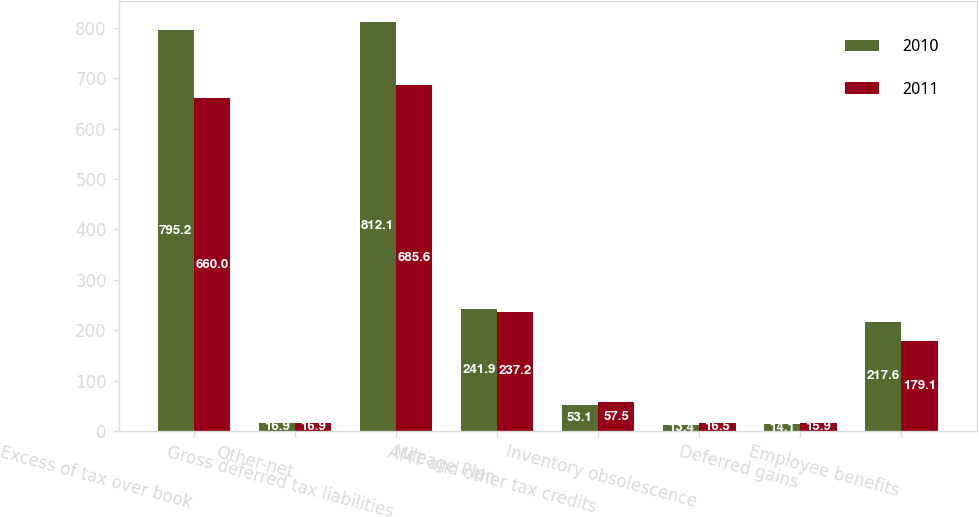Convert chart. <chart><loc_0><loc_0><loc_500><loc_500><stacked_bar_chart><ecel><fcel>Excess of tax over book<fcel>Other-net<fcel>Gross deferred tax liabilities<fcel>Mileage Plan<fcel>AMT and other tax credits<fcel>Inventory obsolescence<fcel>Deferred gains<fcel>Employee benefits<nl><fcel>2010<fcel>795.2<fcel>16.9<fcel>812.1<fcel>241.9<fcel>53.1<fcel>13.4<fcel>14.1<fcel>217.6<nl><fcel>2011<fcel>660<fcel>16.9<fcel>685.6<fcel>237.2<fcel>57.5<fcel>16.5<fcel>15.9<fcel>179.1<nl></chart> 